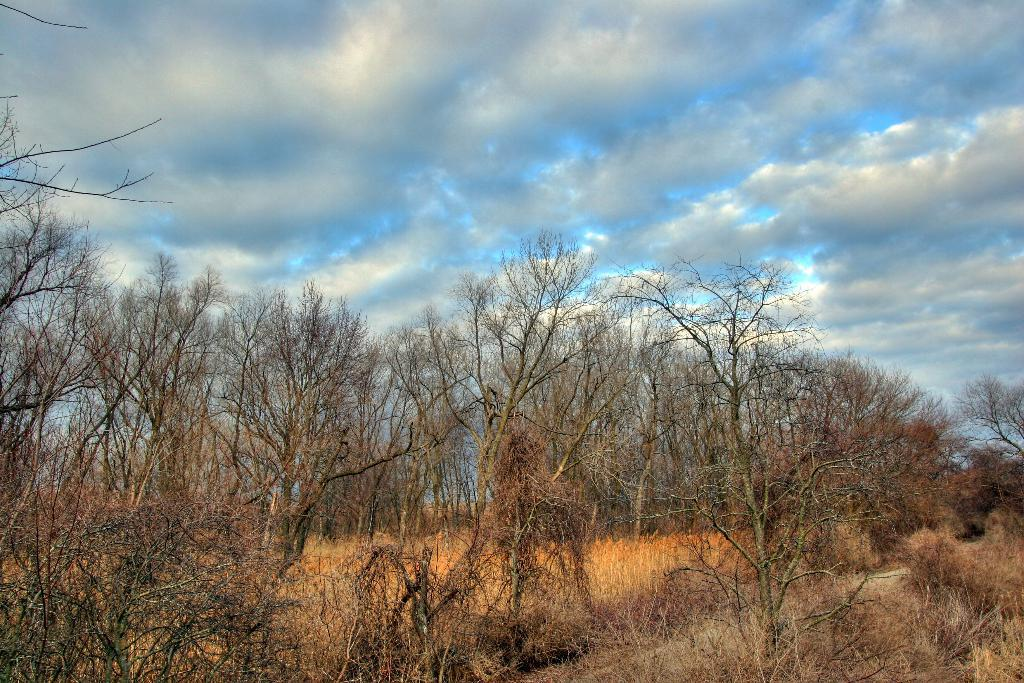Where was the image taken? The image was clicked outside. What can be seen in the middle of the image? There are trees in the middle of the image. What type of vegetation is at the bottom of the image? There is grass at the bottom of the image. What is visible at the top of the image? The sky is visible at the top of the image. What type of truck can be seen driving through the snow in the image? There is no truck or snow present in the image; it features trees, grass, and the sky. What season is depicted in the image? The image does not depict a specific season, as there are no seasonal cues present. 